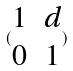<formula> <loc_0><loc_0><loc_500><loc_500>( \begin{matrix} 1 & d \\ 0 & 1 \end{matrix} )</formula> 